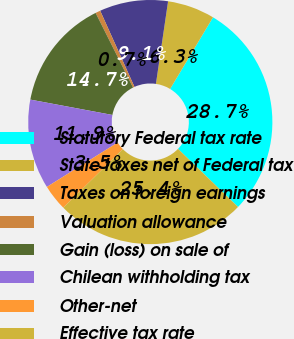<chart> <loc_0><loc_0><loc_500><loc_500><pie_chart><fcel>Statutory Federal tax rate<fcel>State taxes net of Federal tax<fcel>Taxes on foreign earnings<fcel>Valuation allowance<fcel>Gain (loss) on sale of<fcel>Chilean withholding tax<fcel>Other-net<fcel>Effective tax rate<nl><fcel>28.65%<fcel>6.26%<fcel>9.06%<fcel>0.66%<fcel>14.66%<fcel>11.86%<fcel>3.46%<fcel>25.38%<nl></chart> 